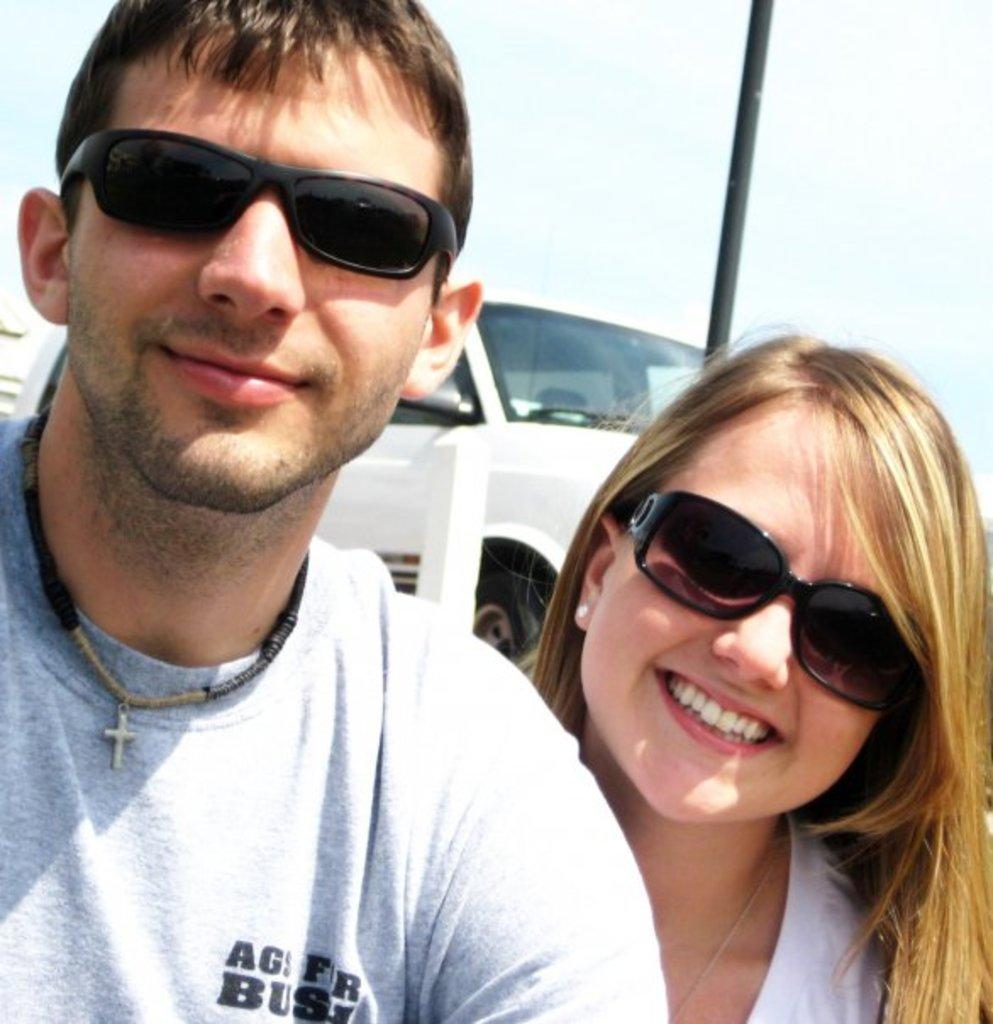How many people are present in the image? There are two people, a man and a woman, present in the image. What are the people in the image doing? Both the man and the woman are smiling. What can be seen on the woman's face? The woman is wearing spectacles. What is visible in the background of the image? There is a vehicle and a pole in the background of the image. Where is the nest located in the image? There is no nest present in the image. What type of respect can be seen between the man and the woman in the image? The image does not show any indication of respect between the man and the woman; it only shows them smiling. 